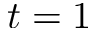<formula> <loc_0><loc_0><loc_500><loc_500>t = 1</formula> 